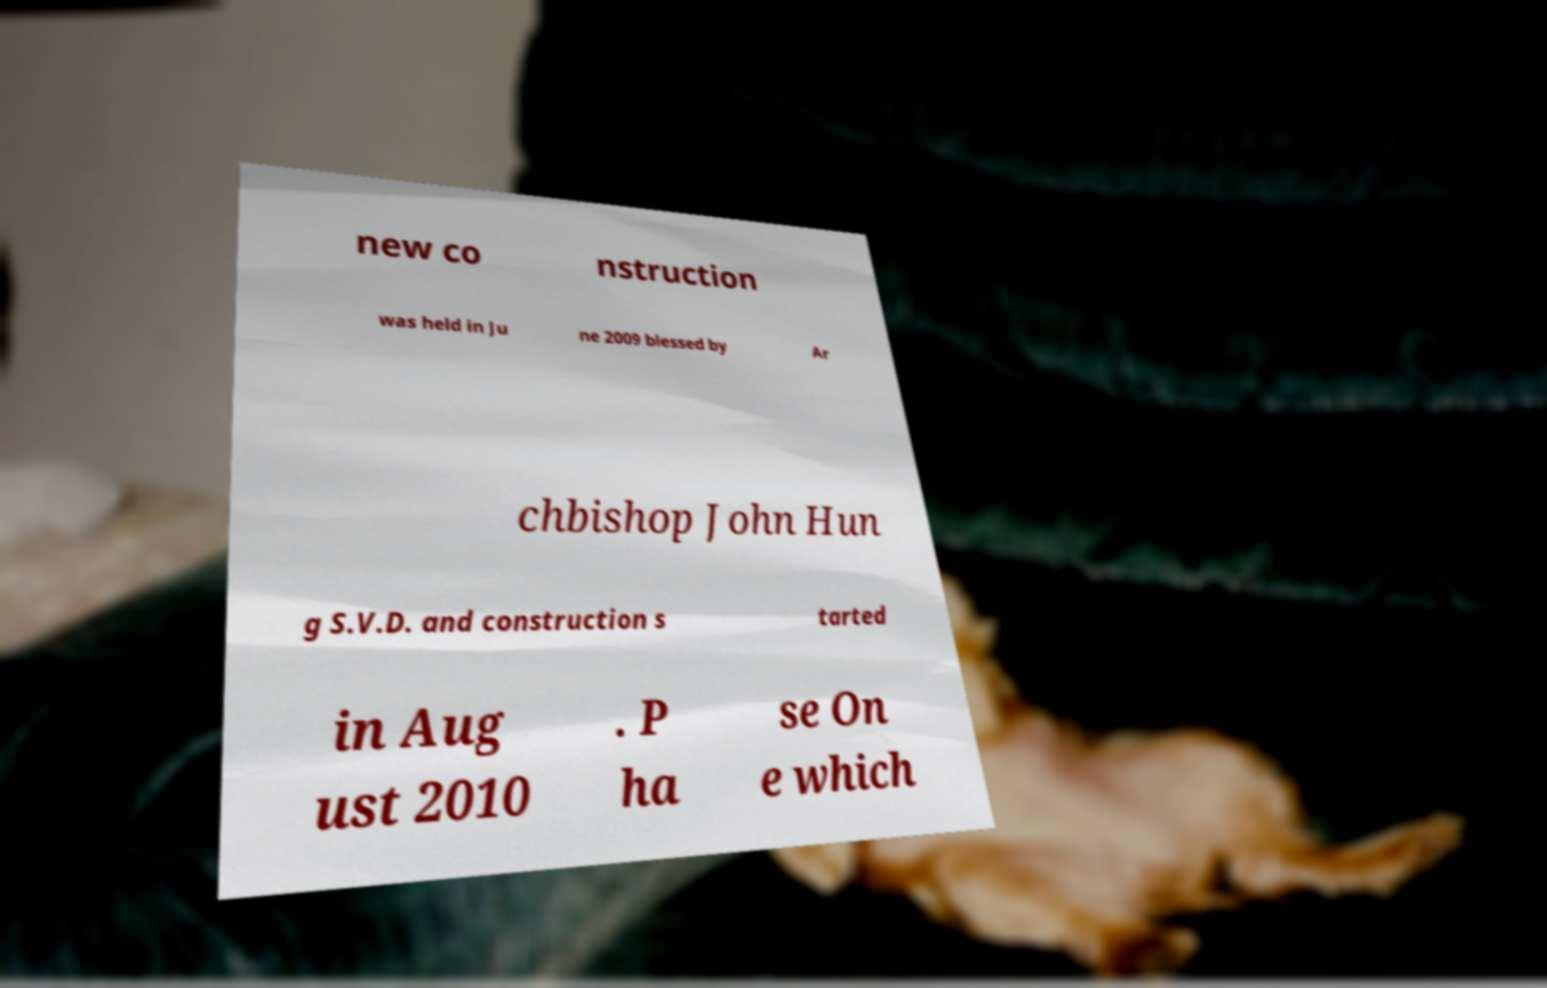Can you read and provide the text displayed in the image?This photo seems to have some interesting text. Can you extract and type it out for me? new co nstruction was held in Ju ne 2009 blessed by Ar chbishop John Hun g S.V.D. and construction s tarted in Aug ust 2010 . P ha se On e which 